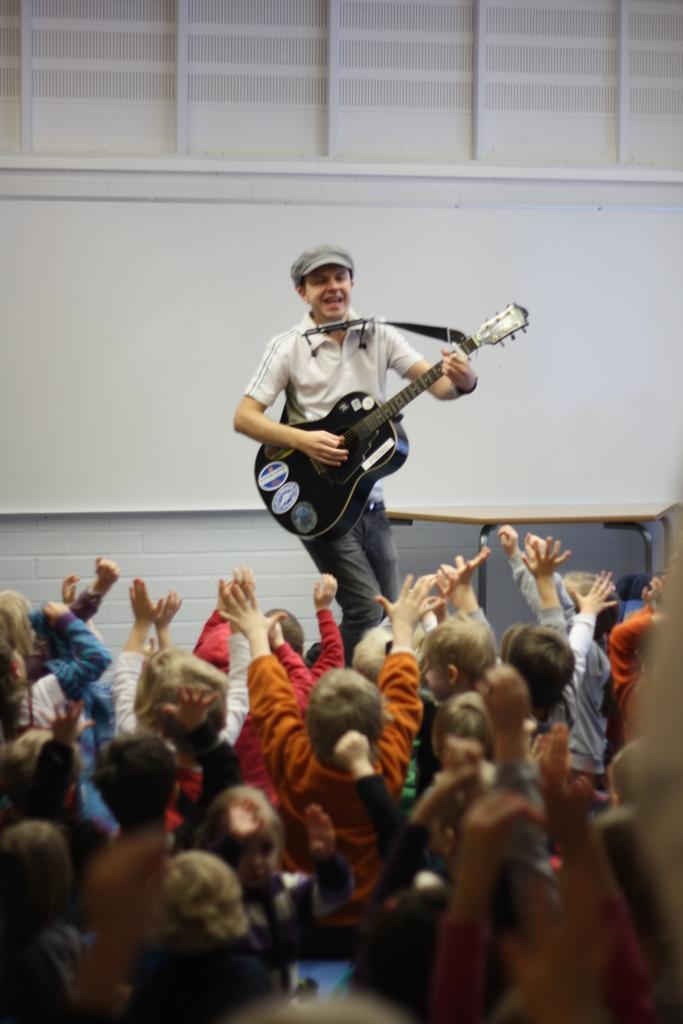How would you summarize this image in a sentence or two? This picture shows a man playing a guitar and we see audience cheering him. 